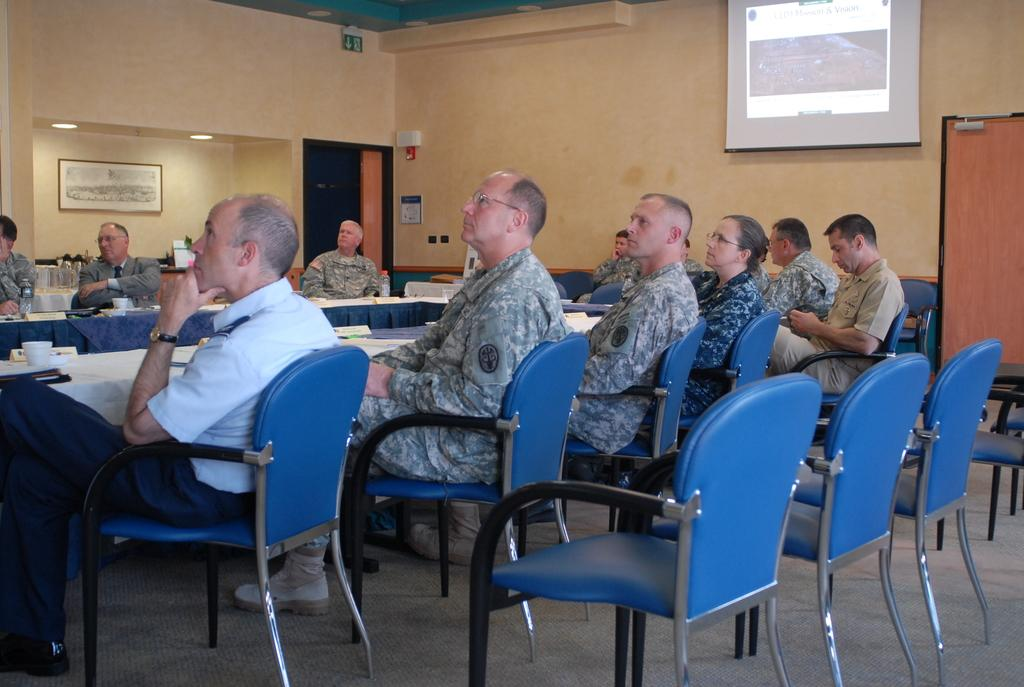What are the people in the image doing? The people in the image are sitting on chairs. How many chairs are visible in the image? There are additional chairs visible in the image besides the ones the people are sitting on. What is on the wall in the image? There is a projector screen on a wall in the image. What type of jelly is being used to mark the territory of the chairs in the image? There is no jelly or territory marking present in the image; people are simply sitting on chairs. 